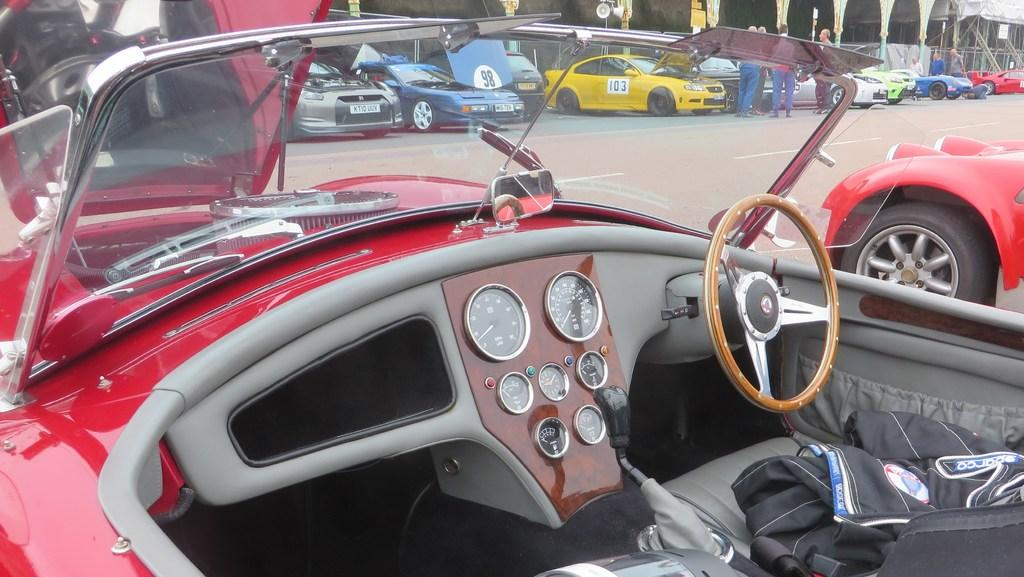What types of objects can be seen in the image? There are vehicles and persons in the image. Where are the vehicles and persons located? The vehicles and persons are on the road. Can you describe the setting in which the vehicles and persons are situated? The vehicles and persons are on a road, which suggests they might be in a public area or a street. What type of bell can be heard ringing in the image? There is no bell present in the image, and therefore no sound can be heard. 